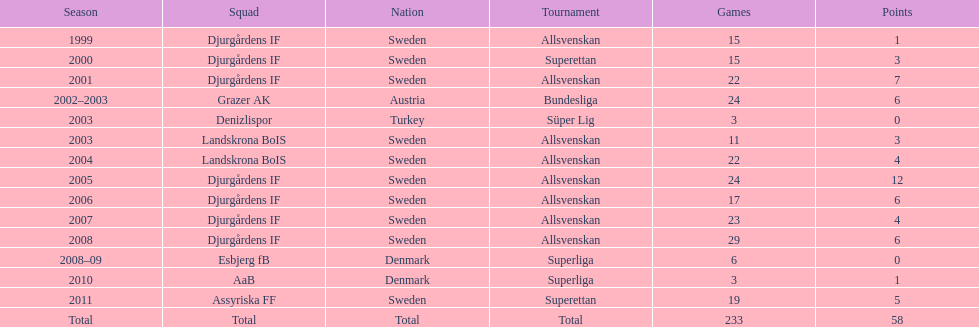What country is team djurgårdens if not from? Sweden. 